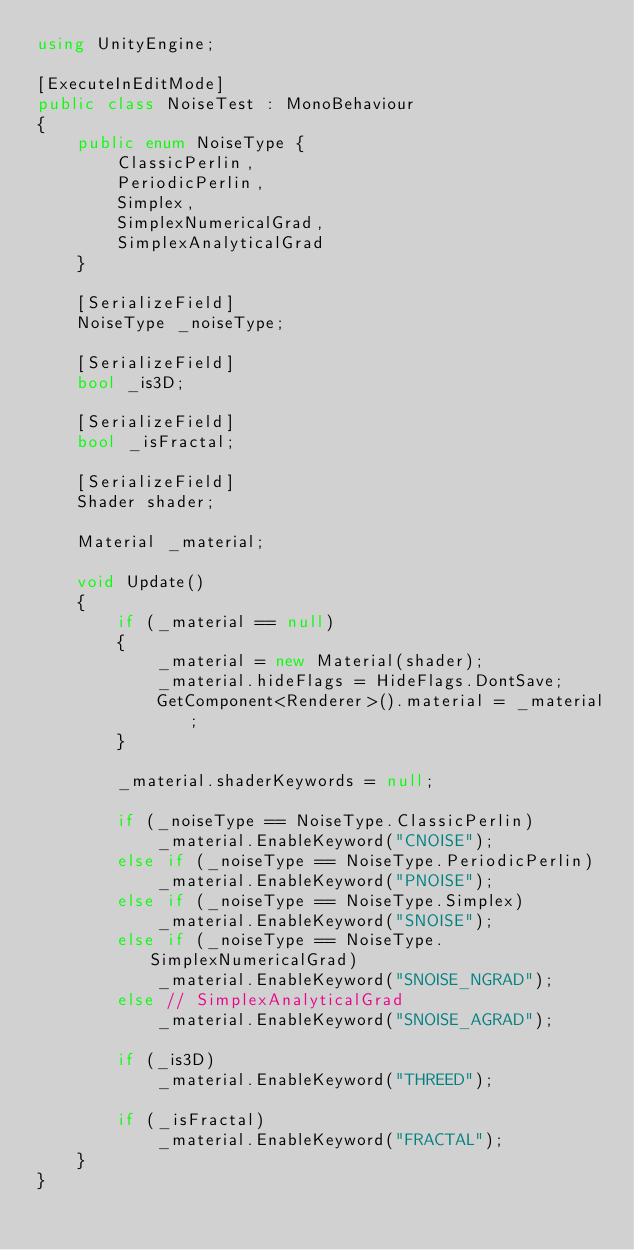Convert code to text. <code><loc_0><loc_0><loc_500><loc_500><_C#_>using UnityEngine;

[ExecuteInEditMode]
public class NoiseTest : MonoBehaviour
{
    public enum NoiseType {
        ClassicPerlin,
        PeriodicPerlin,
        Simplex,
        SimplexNumericalGrad,
        SimplexAnalyticalGrad
    }

    [SerializeField]
    NoiseType _noiseType;

    [SerializeField]
    bool _is3D;

    [SerializeField]
    bool _isFractal;

    [SerializeField]
    Shader shader;

    Material _material;

    void Update()
    {
        if (_material == null)
        {
            _material = new Material(shader);
            _material.hideFlags = HideFlags.DontSave;
            GetComponent<Renderer>().material = _material;
        }

        _material.shaderKeywords = null;

        if (_noiseType == NoiseType.ClassicPerlin)
            _material.EnableKeyword("CNOISE");
        else if (_noiseType == NoiseType.PeriodicPerlin)
            _material.EnableKeyword("PNOISE");
        else if (_noiseType == NoiseType.Simplex)
            _material.EnableKeyword("SNOISE");
        else if (_noiseType == NoiseType.SimplexNumericalGrad)
            _material.EnableKeyword("SNOISE_NGRAD");
        else // SimplexAnalyticalGrad
            _material.EnableKeyword("SNOISE_AGRAD");

        if (_is3D)
            _material.EnableKeyword("THREED");

        if (_isFractal)
            _material.EnableKeyword("FRACTAL");
    }
}
</code> 